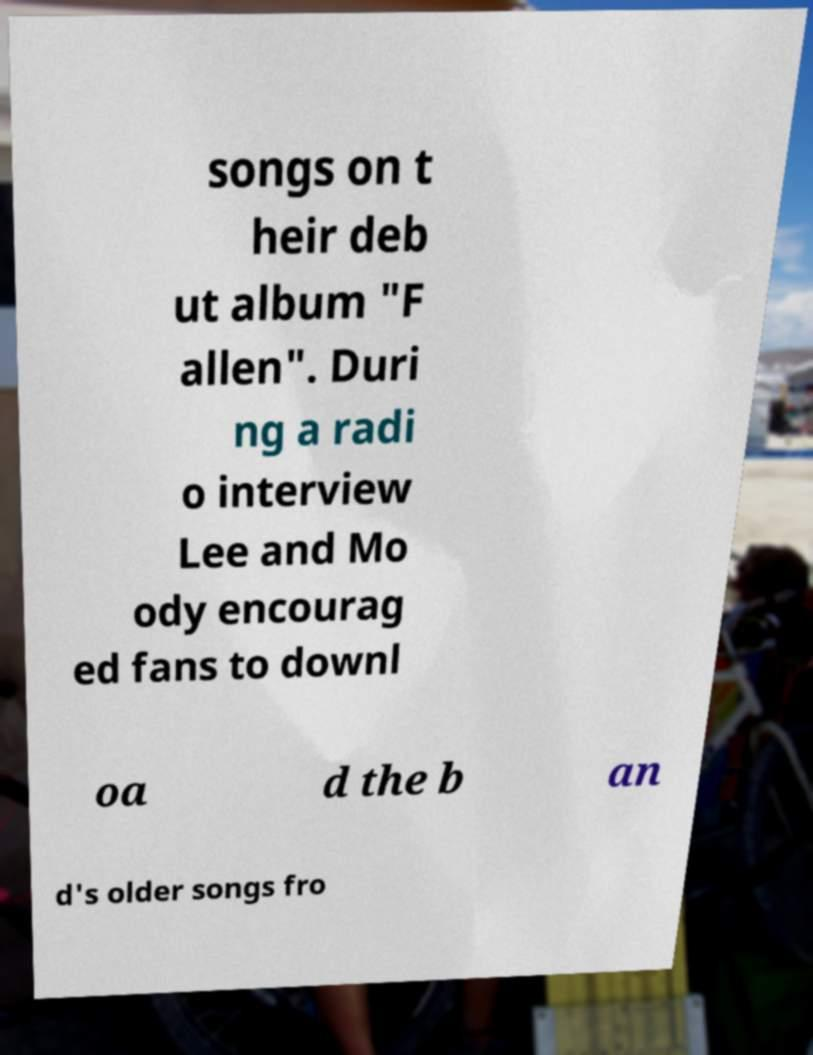Please read and relay the text visible in this image. What does it say? songs on t heir deb ut album "F allen". Duri ng a radi o interview Lee and Mo ody encourag ed fans to downl oa d the b an d's older songs fro 